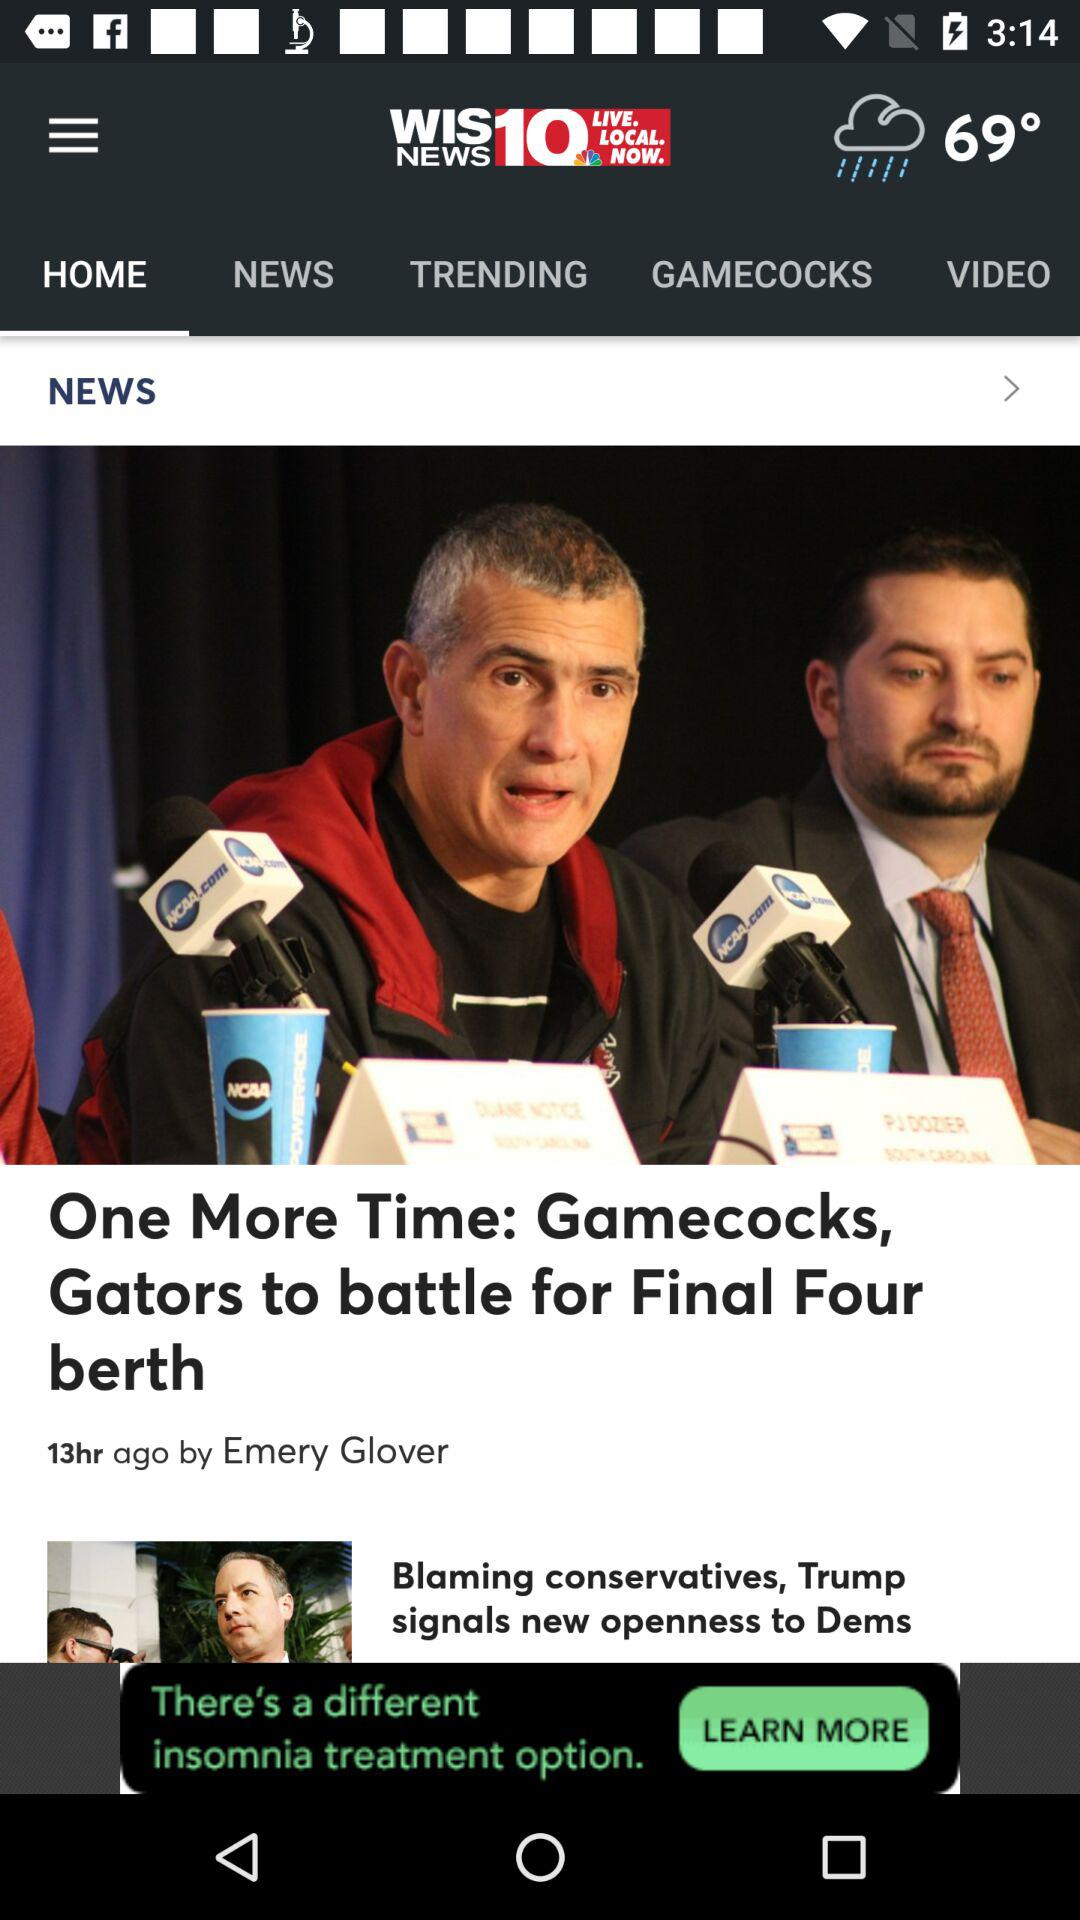What is the temperature? The temperature is 69°. 